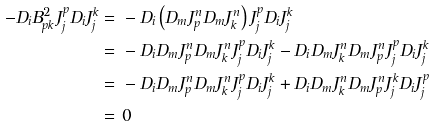Convert formula to latex. <formula><loc_0><loc_0><loc_500><loc_500>- D _ { i } B ^ { 2 } _ { p k } J _ { j } ^ { p } D _ { i } J _ { j } ^ { k } = & \ - D _ { i } \left ( D _ { m } J _ { p } ^ { n } D _ { m } J _ { k } ^ { n } \right ) J _ { j } ^ { p } D _ { i } J _ { j } ^ { k } \\ = & \ - D _ { i } D _ { m } J _ { p } ^ { n } D _ { m } J _ { k } ^ { n } J _ { j } ^ { p } D _ { i } J _ { j } ^ { k } - D _ { i } D _ { m } J _ { k } ^ { n } D _ { m } J _ { p } ^ { n } J _ { j } ^ { p } D _ { i } J _ { j } ^ { k } \\ = & \ - D _ { i } D _ { m } J _ { p } ^ { n } D _ { m } J _ { k } ^ { n } J _ { j } ^ { p } D _ { i } J _ { j } ^ { k } + D _ { i } D _ { m } J _ { k } ^ { n } D _ { m } J _ { p } ^ { n } J _ { j } ^ { k } D _ { i } J _ { j } ^ { p } \\ = & \ 0</formula> 